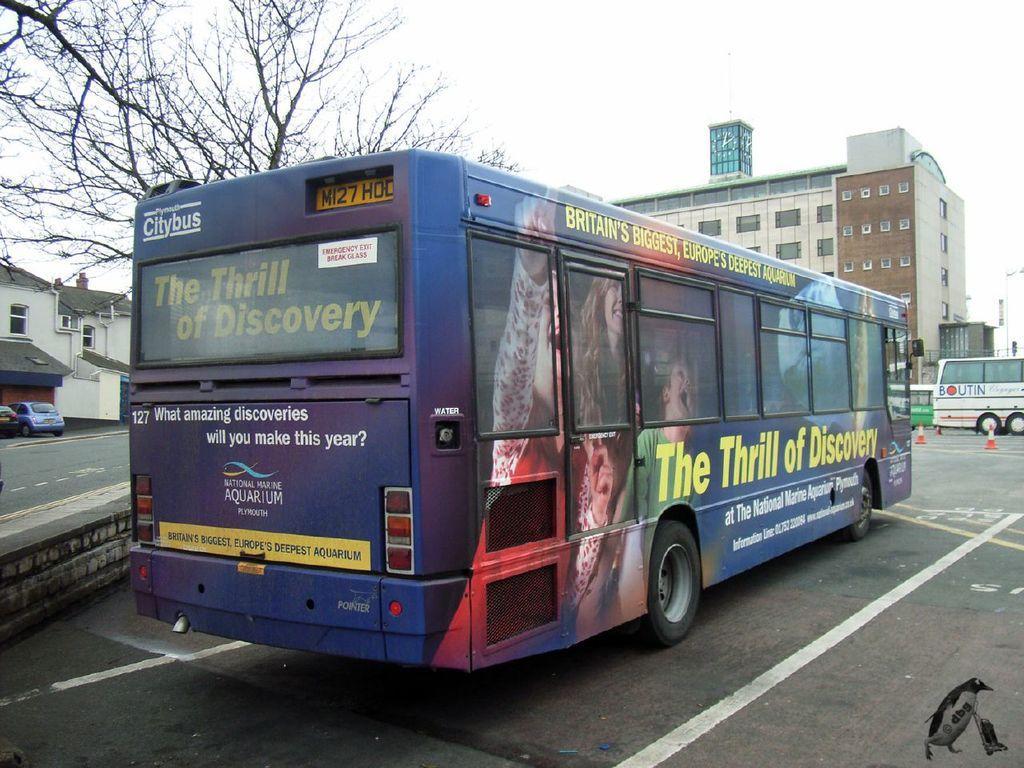Could you give a brief overview of what you see in this image? In this picture we can see buses on the road. On the left side we can see two cars and this is the house. And on the background we can see a building. This is the tree. And we can see the sky here. 